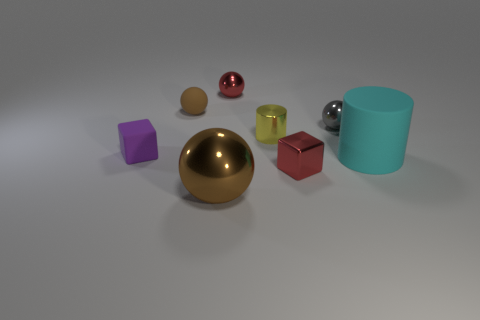Add 2 tiny shiny cylinders. How many objects exist? 10 Subtract all big metallic spheres. How many spheres are left? 3 Subtract all cubes. How many objects are left? 6 Subtract 2 balls. How many balls are left? 2 Subtract all tiny spheres. Subtract all large cyan rubber things. How many objects are left? 4 Add 6 small cubes. How many small cubes are left? 8 Add 4 yellow cylinders. How many yellow cylinders exist? 5 Subtract all yellow cylinders. How many cylinders are left? 1 Subtract 1 red spheres. How many objects are left? 7 Subtract all purple spheres. Subtract all cyan cylinders. How many spheres are left? 4 